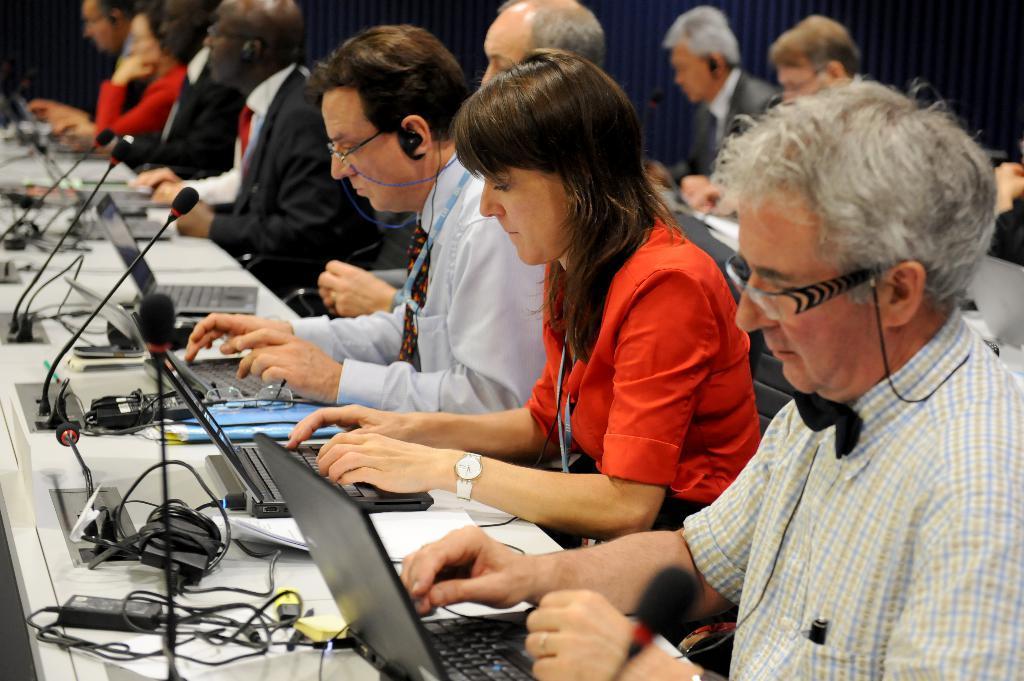In one or two sentences, can you explain what this image depicts? In this image we can see a group of people sitting on the chairs and they are working on the laptops. Here we can see the tables with microphone arrangement. 